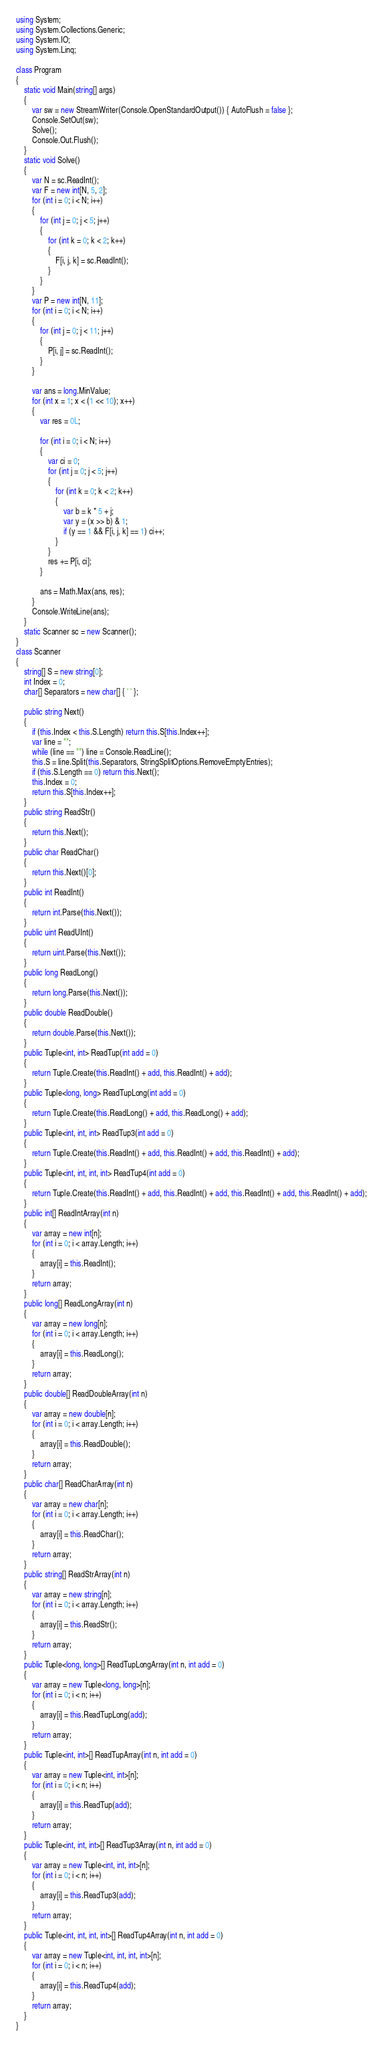<code> <loc_0><loc_0><loc_500><loc_500><_C#_>using System;
using System.Collections.Generic;
using System.IO;
using System.Linq;

class Program
{
    static void Main(string[] args)
    {
        var sw = new StreamWriter(Console.OpenStandardOutput()) { AutoFlush = false };
        Console.SetOut(sw);
        Solve();
        Console.Out.Flush();
    }
    static void Solve()
    {
        var N = sc.ReadInt();
        var F = new int[N, 5, 2];
        for (int i = 0; i < N; i++)
        {
            for (int j = 0; j < 5; j++)
            {
                for (int k = 0; k < 2; k++)
                {
                    F[i, j, k] = sc.ReadInt();
                }
            }
        }
        var P = new int[N, 11];
        for (int i = 0; i < N; i++)
        {
            for (int j = 0; j < 11; j++)
            {
                P[i, j] = sc.ReadInt();
            }
        }

        var ans = long.MinValue;
        for (int x = 1; x < (1 << 10); x++)
        {
            var res = 0L;

            for (int i = 0; i < N; i++)
            {
                var ci = 0;
                for (int j = 0; j < 5; j++)
                {
                    for (int k = 0; k < 2; k++)
                    {
                        var b = k * 5 + j;
                        var y = (x >> b) & 1;
                        if (y == 1 && F[i, j, k] == 1) ci++;
                    }
                }
                res += P[i, ci];
            }

            ans = Math.Max(ans, res);
        }
        Console.WriteLine(ans);
    }
    static Scanner sc = new Scanner();
}
class Scanner
{
    string[] S = new string[0];
    int Index = 0;
    char[] Separators = new char[] { ' ' };

    public string Next()
    {
        if (this.Index < this.S.Length) return this.S[this.Index++];
        var line = "";
        while (line == "") line = Console.ReadLine();
        this.S = line.Split(this.Separators, StringSplitOptions.RemoveEmptyEntries);
        if (this.S.Length == 0) return this.Next();
        this.Index = 0;
        return this.S[this.Index++];
    }
    public string ReadStr()
    {
        return this.Next();
    }
    public char ReadChar()
    {
        return this.Next()[0];
    }
    public int ReadInt()
    {
        return int.Parse(this.Next());
    }
    public uint ReadUInt()
    {
        return uint.Parse(this.Next());
    }
    public long ReadLong()
    {
        return long.Parse(this.Next());
    }
    public double ReadDouble()
    {
        return double.Parse(this.Next());
    }
    public Tuple<int, int> ReadTup(int add = 0)
    {
        return Tuple.Create(this.ReadInt() + add, this.ReadInt() + add);
    }
    public Tuple<long, long> ReadTupLong(int add = 0)
    {
        return Tuple.Create(this.ReadLong() + add, this.ReadLong() + add);
    }
    public Tuple<int, int, int> ReadTup3(int add = 0)
    {
        return Tuple.Create(this.ReadInt() + add, this.ReadInt() + add, this.ReadInt() + add);
    }
    public Tuple<int, int, int, int> ReadTup4(int add = 0)
    {
        return Tuple.Create(this.ReadInt() + add, this.ReadInt() + add, this.ReadInt() + add, this.ReadInt() + add);
    }
    public int[] ReadIntArray(int n)
    {
        var array = new int[n];
        for (int i = 0; i < array.Length; i++)
        {
            array[i] = this.ReadInt();
        }
        return array;
    }
    public long[] ReadLongArray(int n)
    {
        var array = new long[n];
        for (int i = 0; i < array.Length; i++)
        {
            array[i] = this.ReadLong();
        }
        return array;
    }
    public double[] ReadDoubleArray(int n)
    {
        var array = new double[n];
        for (int i = 0; i < array.Length; i++)
        {
            array[i] = this.ReadDouble();
        }
        return array;
    }
    public char[] ReadCharArray(int n)
    {
        var array = new char[n];
        for (int i = 0; i < array.Length; i++)
        {
            array[i] = this.ReadChar();
        }
        return array;
    }
    public string[] ReadStrArray(int n)
    {
        var array = new string[n];
        for (int i = 0; i < array.Length; i++)
        {
            array[i] = this.ReadStr();
        }
        return array;
    }
    public Tuple<long, long>[] ReadTupLongArray(int n, int add = 0)
    {
        var array = new Tuple<long, long>[n];
        for (int i = 0; i < n; i++)
        {
            array[i] = this.ReadTupLong(add);
        }
        return array;
    }
    public Tuple<int, int>[] ReadTupArray(int n, int add = 0)
    {
        var array = new Tuple<int, int>[n];
        for (int i = 0; i < n; i++)
        {
            array[i] = this.ReadTup(add);
        }
        return array;
    }
    public Tuple<int, int, int>[] ReadTup3Array(int n, int add = 0)
    {
        var array = new Tuple<int, int, int>[n];
        for (int i = 0; i < n; i++)
        {
            array[i] = this.ReadTup3(add);
        }
        return array;
    }
    public Tuple<int, int, int, int>[] ReadTup4Array(int n, int add = 0)
    {
        var array = new Tuple<int, int, int, int>[n];
        for (int i = 0; i < n; i++)
        {
            array[i] = this.ReadTup4(add);
        }
        return array;
    }
}
</code> 